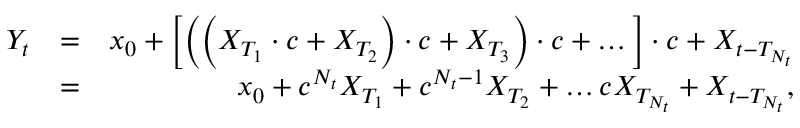<formula> <loc_0><loc_0><loc_500><loc_500>\begin{array} { r l r } { Y _ { t } } & { = } & { x _ { 0 } + \left [ \left ( \left ( X _ { T _ { 1 } } \cdot c + X _ { T _ { 2 } } \right ) \cdot c + X _ { T _ { 3 } } \right ) \cdot c + \dots \right ] \cdot c + X _ { t - T _ { N _ { t } } } } \\ & { = } & { x _ { 0 } + c ^ { N _ { t } } X _ { T _ { 1 } } + c ^ { N _ { t } - 1 } X _ { T _ { 2 } } + \dots c X _ { T _ { N _ { t } } } + X _ { t - T _ { N _ { t } } } , } \end{array}</formula> 